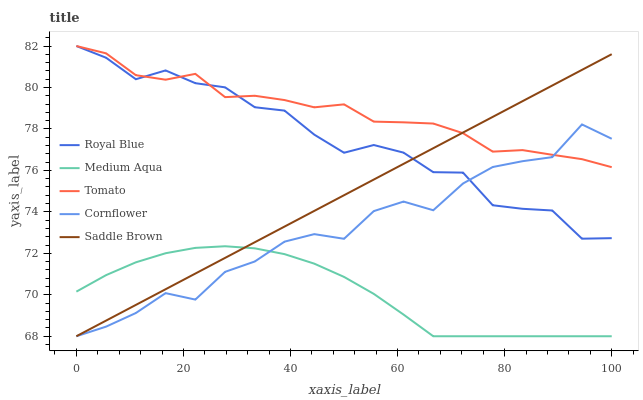Does Medium Aqua have the minimum area under the curve?
Answer yes or no. Yes. Does Tomato have the maximum area under the curve?
Answer yes or no. Yes. Does Royal Blue have the minimum area under the curve?
Answer yes or no. No. Does Royal Blue have the maximum area under the curve?
Answer yes or no. No. Is Saddle Brown the smoothest?
Answer yes or no. Yes. Is Cornflower the roughest?
Answer yes or no. Yes. Is Royal Blue the smoothest?
Answer yes or no. No. Is Royal Blue the roughest?
Answer yes or no. No. Does Medium Aqua have the lowest value?
Answer yes or no. Yes. Does Royal Blue have the lowest value?
Answer yes or no. No. Does Royal Blue have the highest value?
Answer yes or no. Yes. Does Medium Aqua have the highest value?
Answer yes or no. No. Is Medium Aqua less than Royal Blue?
Answer yes or no. Yes. Is Royal Blue greater than Medium Aqua?
Answer yes or no. Yes. Does Royal Blue intersect Saddle Brown?
Answer yes or no. Yes. Is Royal Blue less than Saddle Brown?
Answer yes or no. No. Is Royal Blue greater than Saddle Brown?
Answer yes or no. No. Does Medium Aqua intersect Royal Blue?
Answer yes or no. No. 